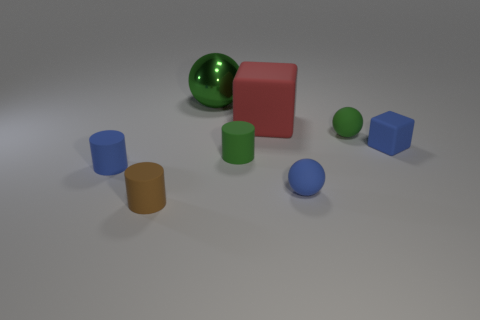Do the tiny thing that is on the left side of the tiny brown matte cylinder and the sphere to the left of the blue sphere have the same material?
Keep it short and to the point. No. Is the number of rubber spheres in front of the tiny blue rubber cylinder the same as the number of large green metallic things that are to the left of the shiny ball?
Your answer should be compact. No. What number of large green spheres are made of the same material as the large red object?
Provide a short and direct response. 0. How big is the matte block that is to the right of the small sphere that is in front of the small blue matte cylinder?
Provide a short and direct response. Small. Do the small blue object left of the small brown cylinder and the small green rubber object on the left side of the tiny green ball have the same shape?
Provide a short and direct response. Yes. Are there the same number of small blue matte blocks on the left side of the small green ball and large purple rubber cubes?
Offer a very short reply. Yes. The other thing that is the same shape as the large red rubber thing is what color?
Keep it short and to the point. Blue. Does the tiny green object that is to the left of the green rubber sphere have the same material as the big sphere?
Your answer should be very brief. No. What number of large things are either brown metallic blocks or blue matte balls?
Your answer should be very brief. 0. How big is the metallic ball?
Offer a very short reply. Large. 